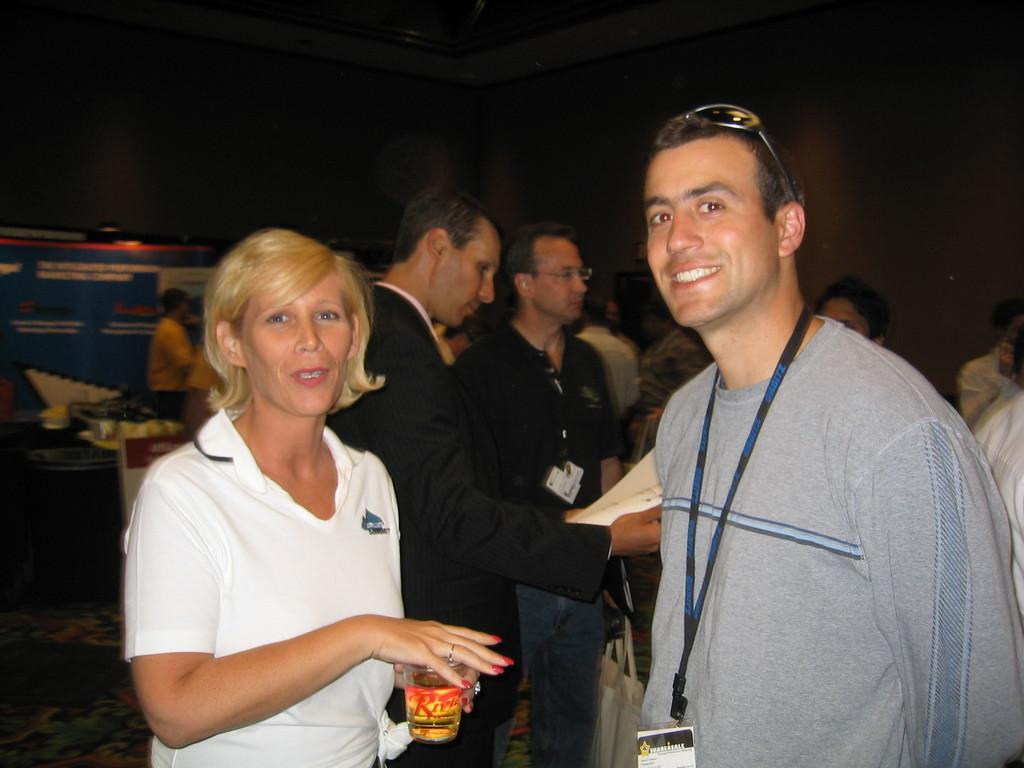Can you describe this image briefly? In the foreground of the picture I can see two persons. I can see a man on the right side wearing a T-shirt and there is a smile on his face. I can see the goggles on his head and there is a tag on his neck. I can see a woman on the left side wearing a white color T-shirt and she is holding a glass in her hand. In the background, I can see a few persons standing on the floor. 